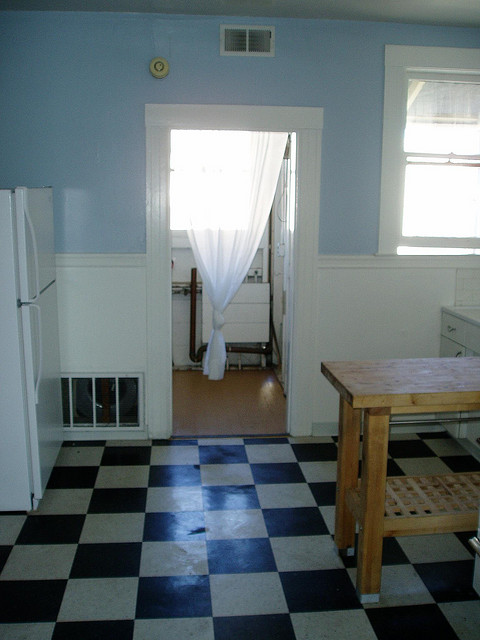<image>What electronic device is on the wall? It is unclear what electronic device is on the wall. It could be a smoke alarm, fire alarm, fridge, or heater. What electronic device is on the wall? I am not sure what electronic device is on the wall. It can be seen as a smoke alarm, fire alarm, or smoke detector. 